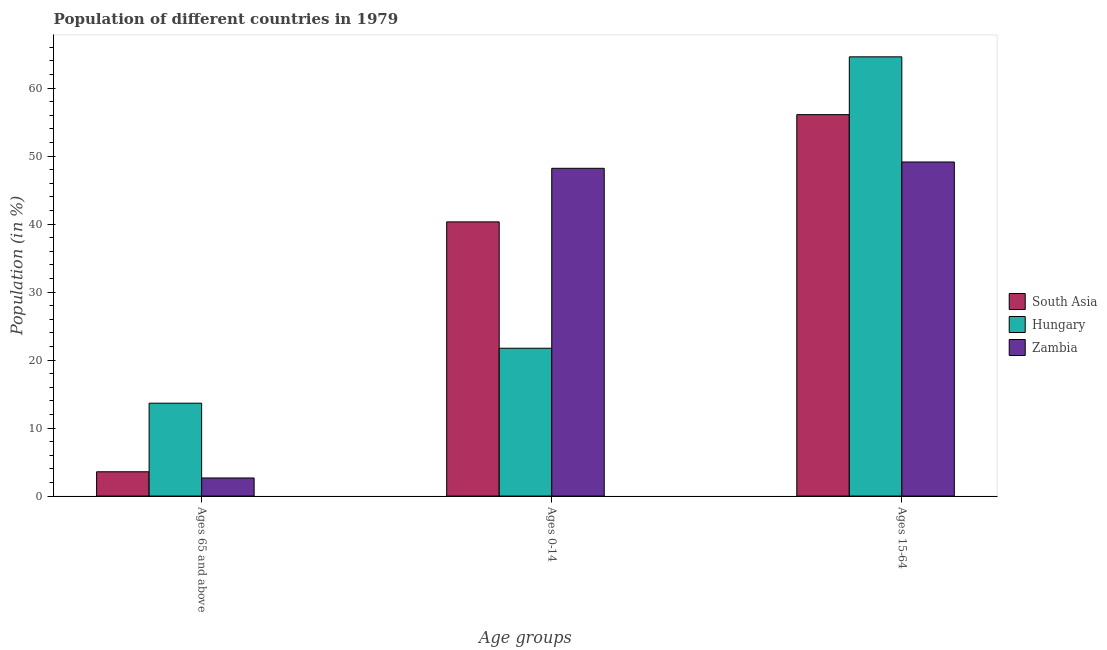How many different coloured bars are there?
Keep it short and to the point. 3. Are the number of bars on each tick of the X-axis equal?
Make the answer very short. Yes. How many bars are there on the 3rd tick from the left?
Give a very brief answer. 3. How many bars are there on the 3rd tick from the right?
Provide a succinct answer. 3. What is the label of the 2nd group of bars from the left?
Give a very brief answer. Ages 0-14. What is the percentage of population within the age-group 0-14 in Zambia?
Provide a short and direct response. 48.21. Across all countries, what is the maximum percentage of population within the age-group 0-14?
Provide a succinct answer. 48.21. Across all countries, what is the minimum percentage of population within the age-group 0-14?
Your response must be concise. 21.74. In which country was the percentage of population within the age-group 0-14 maximum?
Give a very brief answer. Zambia. In which country was the percentage of population within the age-group 15-64 minimum?
Provide a short and direct response. Zambia. What is the total percentage of population within the age-group 15-64 in the graph?
Your answer should be compact. 169.83. What is the difference between the percentage of population within the age-group 15-64 in Hungary and that in Zambia?
Keep it short and to the point. 15.47. What is the difference between the percentage of population within the age-group 0-14 in South Asia and the percentage of population within the age-group 15-64 in Hungary?
Your answer should be compact. -24.27. What is the average percentage of population within the age-group 15-64 per country?
Ensure brevity in your answer.  56.61. What is the difference between the percentage of population within the age-group of 65 and above and percentage of population within the age-group 0-14 in Hungary?
Give a very brief answer. -8.08. In how many countries, is the percentage of population within the age-group of 65 and above greater than 48 %?
Give a very brief answer. 0. What is the ratio of the percentage of population within the age-group of 65 and above in South Asia to that in Zambia?
Your answer should be very brief. 1.34. Is the difference between the percentage of population within the age-group 15-64 in South Asia and Hungary greater than the difference between the percentage of population within the age-group 0-14 in South Asia and Hungary?
Offer a terse response. No. What is the difference between the highest and the second highest percentage of population within the age-group 0-14?
Your answer should be compact. 7.88. What is the difference between the highest and the lowest percentage of population within the age-group of 65 and above?
Ensure brevity in your answer.  11. What does the 1st bar from the left in Ages 0-14 represents?
Offer a very short reply. South Asia. What does the 3rd bar from the right in Ages 15-64 represents?
Offer a terse response. South Asia. Is it the case that in every country, the sum of the percentage of population within the age-group of 65 and above and percentage of population within the age-group 0-14 is greater than the percentage of population within the age-group 15-64?
Keep it short and to the point. No. How many bars are there?
Keep it short and to the point. 9. What is the difference between two consecutive major ticks on the Y-axis?
Ensure brevity in your answer.  10. Are the values on the major ticks of Y-axis written in scientific E-notation?
Your answer should be compact. No. Where does the legend appear in the graph?
Give a very brief answer. Center right. How are the legend labels stacked?
Keep it short and to the point. Vertical. What is the title of the graph?
Ensure brevity in your answer.  Population of different countries in 1979. What is the label or title of the X-axis?
Your answer should be compact. Age groups. What is the label or title of the Y-axis?
Provide a short and direct response. Population (in %). What is the Population (in %) of South Asia in Ages 65 and above?
Keep it short and to the point. 3.57. What is the Population (in %) in Hungary in Ages 65 and above?
Provide a short and direct response. 13.66. What is the Population (in %) of Zambia in Ages 65 and above?
Offer a terse response. 2.66. What is the Population (in %) of South Asia in Ages 0-14?
Give a very brief answer. 40.33. What is the Population (in %) in Hungary in Ages 0-14?
Provide a succinct answer. 21.74. What is the Population (in %) of Zambia in Ages 0-14?
Give a very brief answer. 48.21. What is the Population (in %) in South Asia in Ages 15-64?
Offer a very short reply. 56.1. What is the Population (in %) of Hungary in Ages 15-64?
Offer a terse response. 64.6. What is the Population (in %) of Zambia in Ages 15-64?
Give a very brief answer. 49.13. Across all Age groups, what is the maximum Population (in %) of South Asia?
Provide a succinct answer. 56.1. Across all Age groups, what is the maximum Population (in %) of Hungary?
Make the answer very short. 64.6. Across all Age groups, what is the maximum Population (in %) of Zambia?
Your answer should be compact. 49.13. Across all Age groups, what is the minimum Population (in %) in South Asia?
Provide a short and direct response. 3.57. Across all Age groups, what is the minimum Population (in %) in Hungary?
Provide a short and direct response. 13.66. Across all Age groups, what is the minimum Population (in %) of Zambia?
Your answer should be very brief. 2.66. What is the difference between the Population (in %) in South Asia in Ages 65 and above and that in Ages 0-14?
Make the answer very short. -36.75. What is the difference between the Population (in %) of Hungary in Ages 65 and above and that in Ages 0-14?
Make the answer very short. -8.08. What is the difference between the Population (in %) of Zambia in Ages 65 and above and that in Ages 0-14?
Your response must be concise. -45.55. What is the difference between the Population (in %) of South Asia in Ages 65 and above and that in Ages 15-64?
Offer a terse response. -52.53. What is the difference between the Population (in %) in Hungary in Ages 65 and above and that in Ages 15-64?
Give a very brief answer. -50.94. What is the difference between the Population (in %) of Zambia in Ages 65 and above and that in Ages 15-64?
Provide a short and direct response. -46.47. What is the difference between the Population (in %) of South Asia in Ages 0-14 and that in Ages 15-64?
Provide a short and direct response. -15.77. What is the difference between the Population (in %) of Hungary in Ages 0-14 and that in Ages 15-64?
Your answer should be compact. -42.86. What is the difference between the Population (in %) of Zambia in Ages 0-14 and that in Ages 15-64?
Offer a terse response. -0.93. What is the difference between the Population (in %) in South Asia in Ages 65 and above and the Population (in %) in Hungary in Ages 0-14?
Provide a short and direct response. -18.17. What is the difference between the Population (in %) in South Asia in Ages 65 and above and the Population (in %) in Zambia in Ages 0-14?
Ensure brevity in your answer.  -44.63. What is the difference between the Population (in %) in Hungary in Ages 65 and above and the Population (in %) in Zambia in Ages 0-14?
Your response must be concise. -34.55. What is the difference between the Population (in %) of South Asia in Ages 65 and above and the Population (in %) of Hungary in Ages 15-64?
Your response must be concise. -61.03. What is the difference between the Population (in %) in South Asia in Ages 65 and above and the Population (in %) in Zambia in Ages 15-64?
Make the answer very short. -45.56. What is the difference between the Population (in %) of Hungary in Ages 65 and above and the Population (in %) of Zambia in Ages 15-64?
Your answer should be compact. -35.47. What is the difference between the Population (in %) in South Asia in Ages 0-14 and the Population (in %) in Hungary in Ages 15-64?
Give a very brief answer. -24.27. What is the difference between the Population (in %) in South Asia in Ages 0-14 and the Population (in %) in Zambia in Ages 15-64?
Your response must be concise. -8.81. What is the difference between the Population (in %) in Hungary in Ages 0-14 and the Population (in %) in Zambia in Ages 15-64?
Your answer should be compact. -27.39. What is the average Population (in %) of South Asia per Age groups?
Your answer should be compact. 33.33. What is the average Population (in %) of Hungary per Age groups?
Offer a very short reply. 33.33. What is the average Population (in %) of Zambia per Age groups?
Your response must be concise. 33.33. What is the difference between the Population (in %) in South Asia and Population (in %) in Hungary in Ages 65 and above?
Ensure brevity in your answer.  -10.09. What is the difference between the Population (in %) of South Asia and Population (in %) of Zambia in Ages 65 and above?
Ensure brevity in your answer.  0.91. What is the difference between the Population (in %) of Hungary and Population (in %) of Zambia in Ages 65 and above?
Provide a succinct answer. 11. What is the difference between the Population (in %) in South Asia and Population (in %) in Hungary in Ages 0-14?
Offer a terse response. 18.59. What is the difference between the Population (in %) in South Asia and Population (in %) in Zambia in Ages 0-14?
Give a very brief answer. -7.88. What is the difference between the Population (in %) of Hungary and Population (in %) of Zambia in Ages 0-14?
Offer a very short reply. -26.47. What is the difference between the Population (in %) in South Asia and Population (in %) in Hungary in Ages 15-64?
Ensure brevity in your answer.  -8.5. What is the difference between the Population (in %) of South Asia and Population (in %) of Zambia in Ages 15-64?
Your answer should be very brief. 6.97. What is the difference between the Population (in %) in Hungary and Population (in %) in Zambia in Ages 15-64?
Give a very brief answer. 15.47. What is the ratio of the Population (in %) in South Asia in Ages 65 and above to that in Ages 0-14?
Your response must be concise. 0.09. What is the ratio of the Population (in %) in Hungary in Ages 65 and above to that in Ages 0-14?
Give a very brief answer. 0.63. What is the ratio of the Population (in %) of Zambia in Ages 65 and above to that in Ages 0-14?
Give a very brief answer. 0.06. What is the ratio of the Population (in %) of South Asia in Ages 65 and above to that in Ages 15-64?
Your answer should be compact. 0.06. What is the ratio of the Population (in %) of Hungary in Ages 65 and above to that in Ages 15-64?
Ensure brevity in your answer.  0.21. What is the ratio of the Population (in %) in Zambia in Ages 65 and above to that in Ages 15-64?
Give a very brief answer. 0.05. What is the ratio of the Population (in %) in South Asia in Ages 0-14 to that in Ages 15-64?
Your answer should be very brief. 0.72. What is the ratio of the Population (in %) in Hungary in Ages 0-14 to that in Ages 15-64?
Ensure brevity in your answer.  0.34. What is the ratio of the Population (in %) of Zambia in Ages 0-14 to that in Ages 15-64?
Your response must be concise. 0.98. What is the difference between the highest and the second highest Population (in %) of South Asia?
Give a very brief answer. 15.77. What is the difference between the highest and the second highest Population (in %) in Hungary?
Ensure brevity in your answer.  42.86. What is the difference between the highest and the second highest Population (in %) of Zambia?
Keep it short and to the point. 0.93. What is the difference between the highest and the lowest Population (in %) in South Asia?
Your answer should be compact. 52.53. What is the difference between the highest and the lowest Population (in %) of Hungary?
Your answer should be compact. 50.94. What is the difference between the highest and the lowest Population (in %) in Zambia?
Your response must be concise. 46.47. 